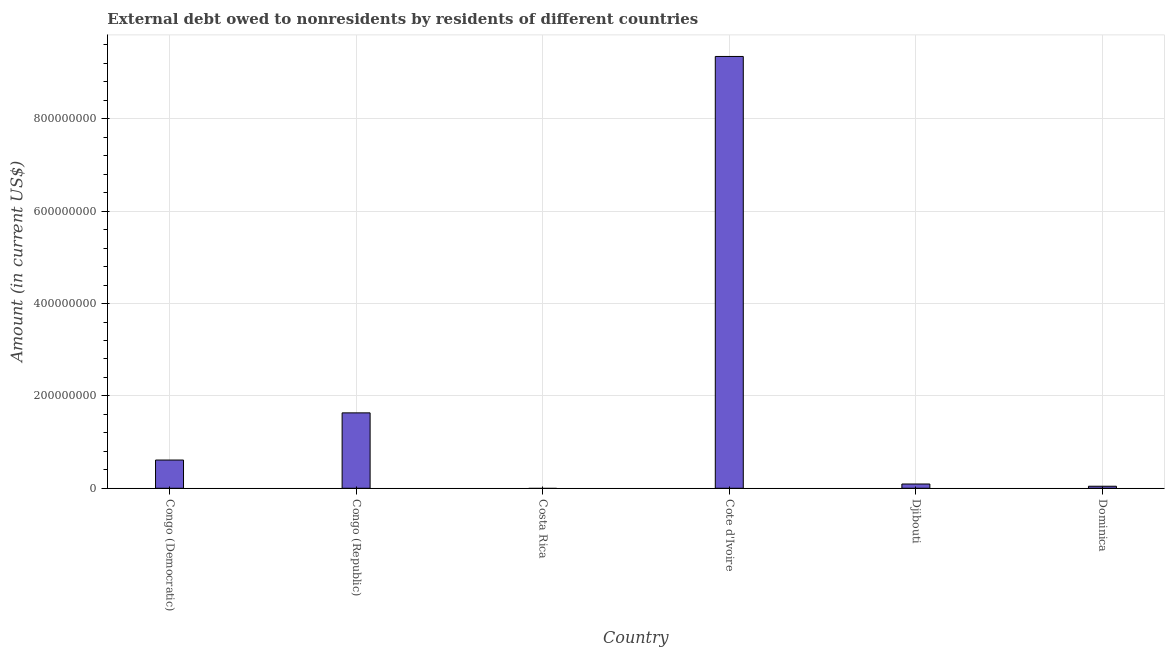Does the graph contain grids?
Give a very brief answer. Yes. What is the title of the graph?
Give a very brief answer. External debt owed to nonresidents by residents of different countries. What is the debt in Costa Rica?
Offer a very short reply. 0. Across all countries, what is the maximum debt?
Provide a short and direct response. 9.35e+08. In which country was the debt maximum?
Keep it short and to the point. Cote d'Ivoire. What is the sum of the debt?
Ensure brevity in your answer.  1.17e+09. What is the difference between the debt in Djibouti and Dominica?
Make the answer very short. 4.82e+06. What is the average debt per country?
Keep it short and to the point. 1.96e+08. What is the median debt?
Your answer should be compact. 3.52e+07. In how many countries, is the debt greater than 320000000 US$?
Offer a very short reply. 1. What is the ratio of the debt in Congo (Republic) to that in Djibouti?
Ensure brevity in your answer.  17.68. What is the difference between the highest and the second highest debt?
Keep it short and to the point. 7.72e+08. Is the sum of the debt in Congo (Democratic) and Djibouti greater than the maximum debt across all countries?
Your answer should be compact. No. What is the difference between the highest and the lowest debt?
Keep it short and to the point. 9.35e+08. How many bars are there?
Make the answer very short. 5. How many countries are there in the graph?
Your answer should be compact. 6. What is the difference between two consecutive major ticks on the Y-axis?
Offer a terse response. 2.00e+08. What is the Amount (in current US$) in Congo (Democratic)?
Offer a terse response. 6.11e+07. What is the Amount (in current US$) in Congo (Republic)?
Your answer should be compact. 1.63e+08. What is the Amount (in current US$) of Cote d'Ivoire?
Your answer should be very brief. 9.35e+08. What is the Amount (in current US$) in Djibouti?
Keep it short and to the point. 9.24e+06. What is the Amount (in current US$) of Dominica?
Your answer should be compact. 4.42e+06. What is the difference between the Amount (in current US$) in Congo (Democratic) and Congo (Republic)?
Make the answer very short. -1.02e+08. What is the difference between the Amount (in current US$) in Congo (Democratic) and Cote d'Ivoire?
Your answer should be compact. -8.74e+08. What is the difference between the Amount (in current US$) in Congo (Democratic) and Djibouti?
Ensure brevity in your answer.  5.19e+07. What is the difference between the Amount (in current US$) in Congo (Democratic) and Dominica?
Keep it short and to the point. 5.67e+07. What is the difference between the Amount (in current US$) in Congo (Republic) and Cote d'Ivoire?
Offer a terse response. -7.72e+08. What is the difference between the Amount (in current US$) in Congo (Republic) and Djibouti?
Your answer should be very brief. 1.54e+08. What is the difference between the Amount (in current US$) in Congo (Republic) and Dominica?
Give a very brief answer. 1.59e+08. What is the difference between the Amount (in current US$) in Cote d'Ivoire and Djibouti?
Ensure brevity in your answer.  9.26e+08. What is the difference between the Amount (in current US$) in Cote d'Ivoire and Dominica?
Make the answer very short. 9.31e+08. What is the difference between the Amount (in current US$) in Djibouti and Dominica?
Offer a very short reply. 4.82e+06. What is the ratio of the Amount (in current US$) in Congo (Democratic) to that in Congo (Republic)?
Provide a short and direct response. 0.37. What is the ratio of the Amount (in current US$) in Congo (Democratic) to that in Cote d'Ivoire?
Your answer should be very brief. 0.07. What is the ratio of the Amount (in current US$) in Congo (Democratic) to that in Djibouti?
Your answer should be compact. 6.62. What is the ratio of the Amount (in current US$) in Congo (Democratic) to that in Dominica?
Your response must be concise. 13.84. What is the ratio of the Amount (in current US$) in Congo (Republic) to that in Cote d'Ivoire?
Your response must be concise. 0.17. What is the ratio of the Amount (in current US$) in Congo (Republic) to that in Djibouti?
Make the answer very short. 17.68. What is the ratio of the Amount (in current US$) in Congo (Republic) to that in Dominica?
Make the answer very short. 36.97. What is the ratio of the Amount (in current US$) in Cote d'Ivoire to that in Djibouti?
Give a very brief answer. 101.21. What is the ratio of the Amount (in current US$) in Cote d'Ivoire to that in Dominica?
Offer a very short reply. 211.72. What is the ratio of the Amount (in current US$) in Djibouti to that in Dominica?
Your answer should be very brief. 2.09. 